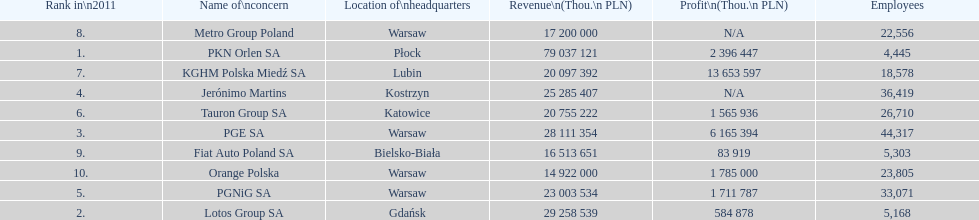Which company had the most employees? PGE SA. 